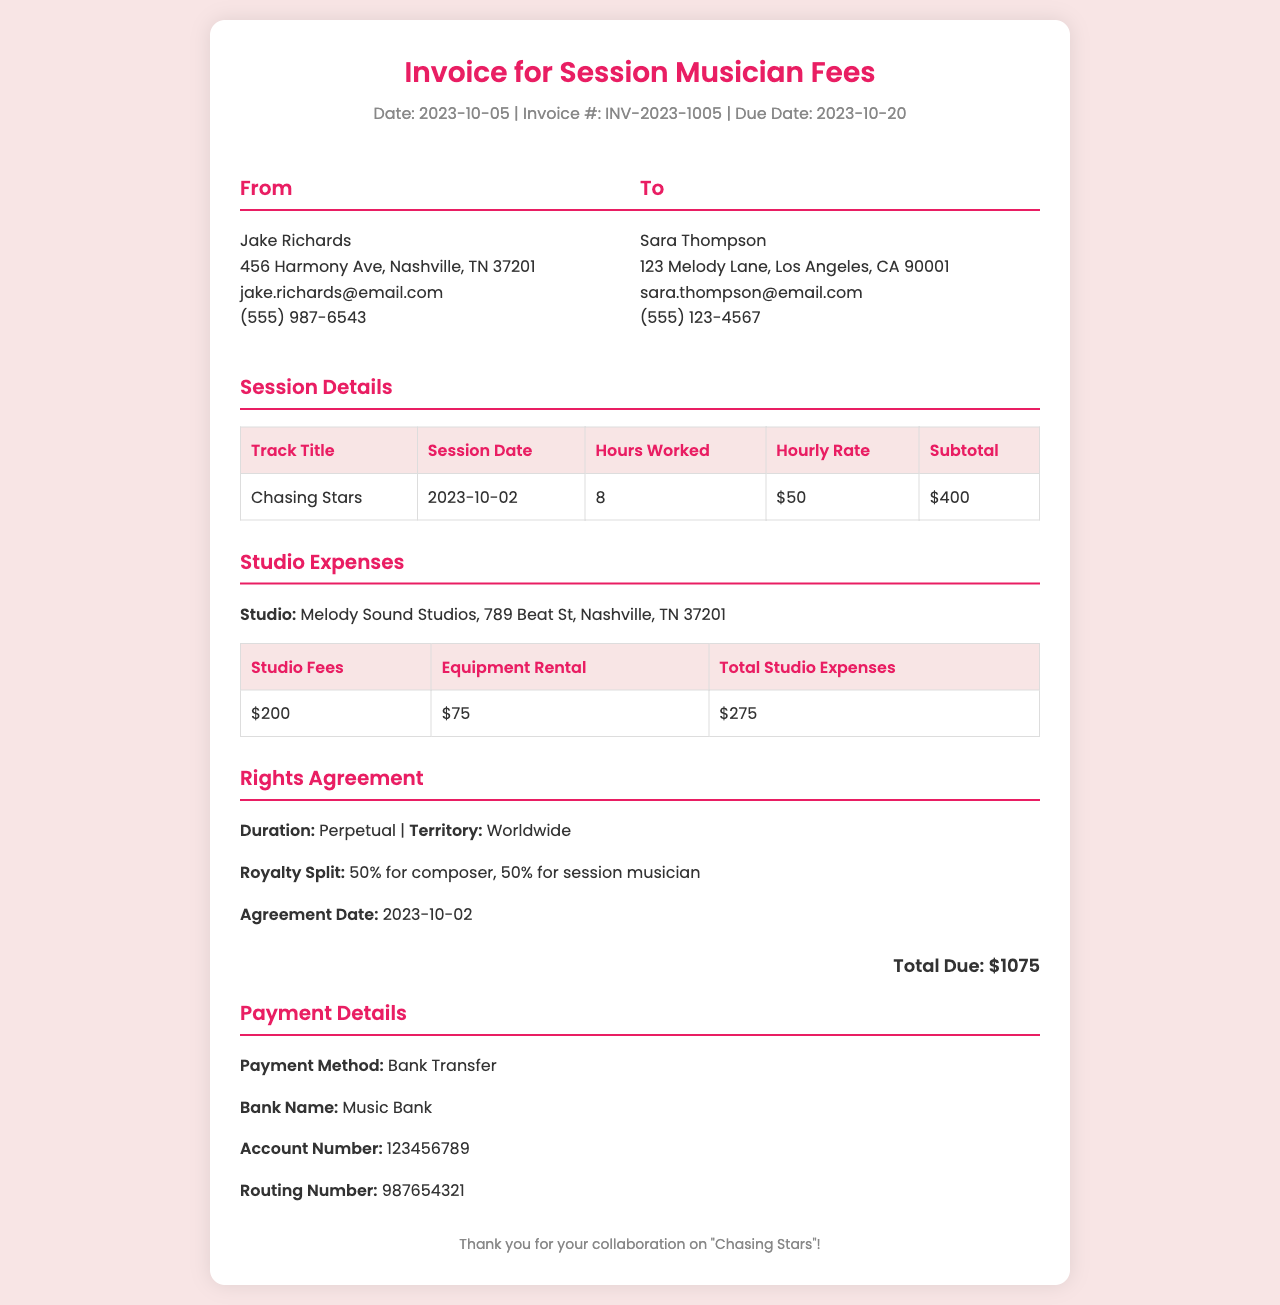What is the invoice date? The invoice date is stated clearly at the top of the document.
Answer: 2023-10-05 Who is the session musician? The name of the session musician is mentioned in the "From" section of the invoice.
Answer: Jake Richards What is the track title? The track title is listed in the "Session Details" section of the invoice.
Answer: Chasing Stars How many hours were worked on the track? The number of hours worked is specified in the "Session Details" section of the invoice.
Answer: 8 What is the hourly rate for the session musician? The hourly rate is provided in the "Session Details" section of the invoice.
Answer: $50 What is the total studio expense? The total studio expense is summarized in the "Studio Expenses" section of the invoice.
Answer: $275 What is the royalty split for the rights agreement? The royalty split is detailed in the "Rights Agreement" section of the invoice.
Answer: 50% for composer, 50% for session musician What is the total amount due? The total amount due is listed at the bottom of the invoice.
Answer: $1075 What is the payment method specified in the invoice? The payment method is provided in the "Payment Details" section of the invoice.
Answer: Bank Transfer 